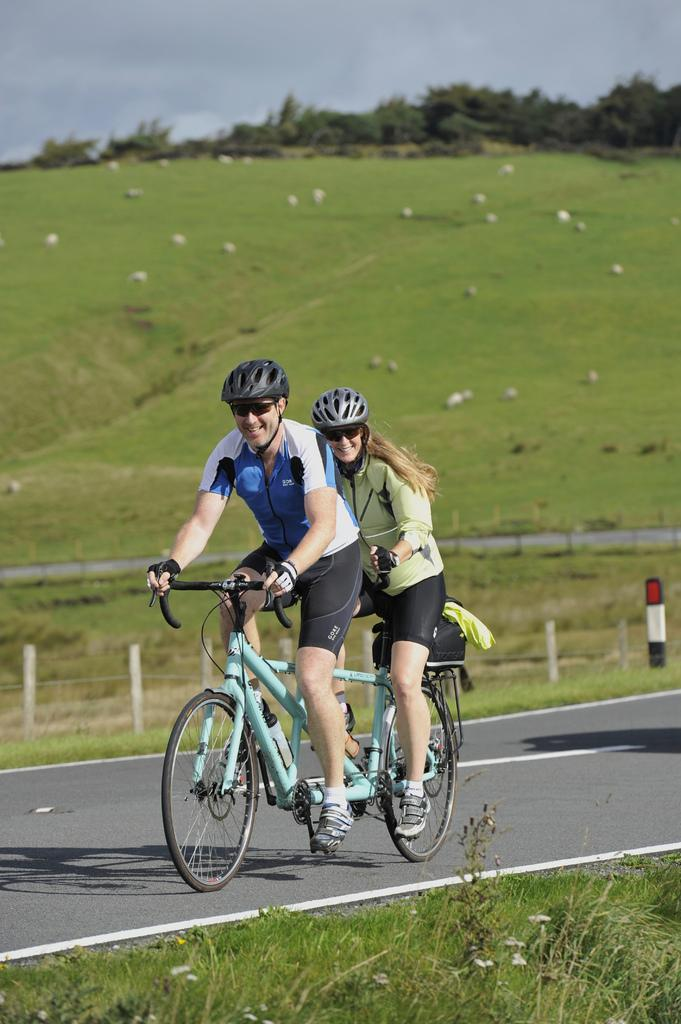How many people are in the image? There are two people in the image, a man and a woman. What are they wearing on their heads? Both the man and woman are wearing helmets. What expressions do they have on their faces? The man and woman are smiling. What activity are they engaged in? They are riding bicycles on a road. What type of environment can be seen in the image? There is grass visible in the image, and there are trees present in the background. What language is being spoken in the lunchroom in the image? There is no lunchroom present in the image, and therefore no language being spoken. 